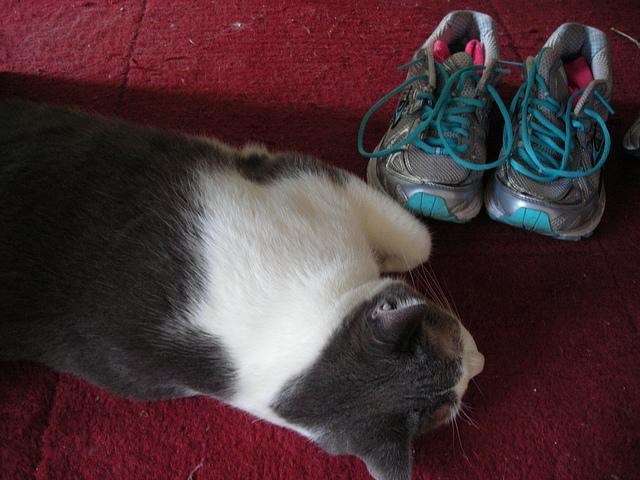How many shoes are visible in the photo?
Give a very brief answer. 2. How many people are around the table?
Give a very brief answer. 0. 